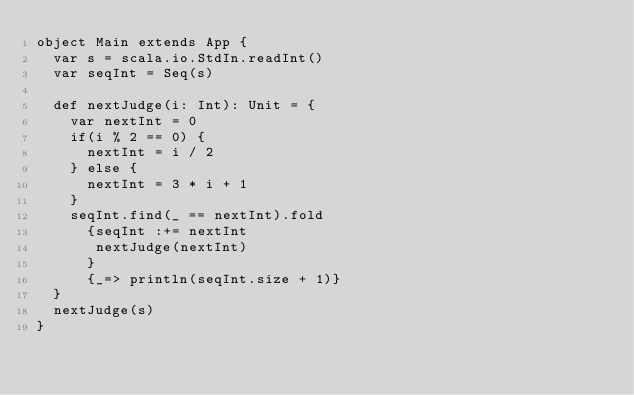<code> <loc_0><loc_0><loc_500><loc_500><_Scala_>object Main extends App {
  var s = scala.io.StdIn.readInt()
  var seqInt = Seq(s)

  def nextJudge(i: Int): Unit = {
    var nextInt = 0
    if(i % 2 == 0) {
      nextInt = i / 2
    } else {
      nextInt = 3 * i + 1
    }
    seqInt.find(_ == nextInt).fold
      {seqInt :+= nextInt
       nextJudge(nextInt)
      }
      {_=> println(seqInt.size + 1)}
  }
  nextJudge(s)
}</code> 